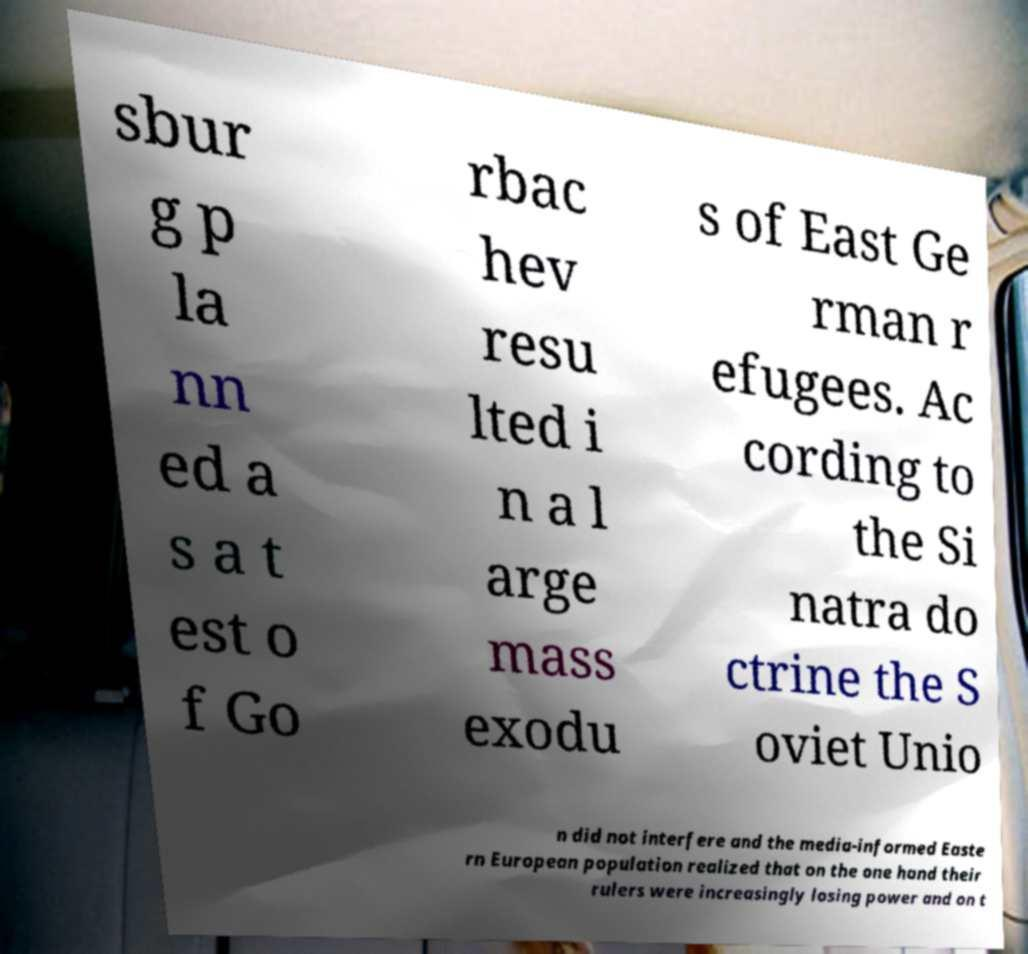I need the written content from this picture converted into text. Can you do that? sbur g p la nn ed a s a t est o f Go rbac hev resu lted i n a l arge mass exodu s of East Ge rman r efugees. Ac cording to the Si natra do ctrine the S oviet Unio n did not interfere and the media-informed Easte rn European population realized that on the one hand their rulers were increasingly losing power and on t 